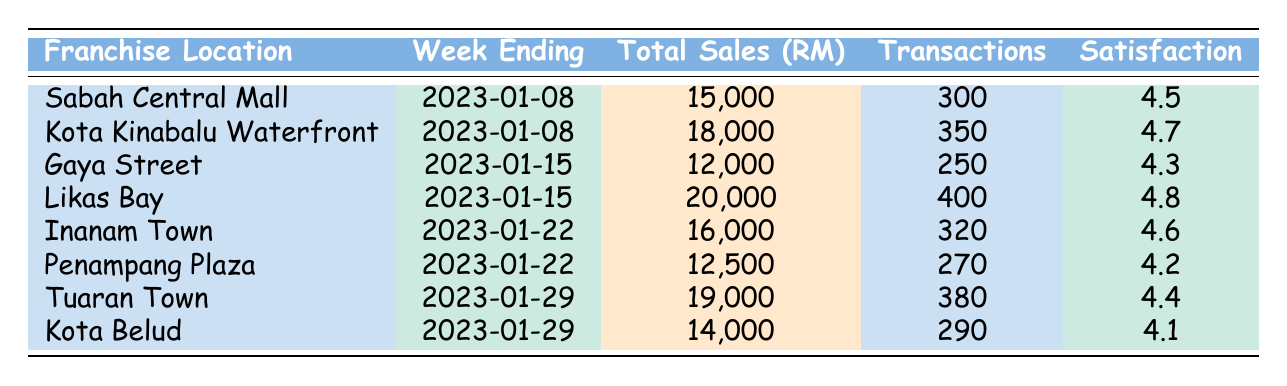What was the highest total sales recorded in a week and where was it? From the table, we look at the Total Sales column. The highest value is 20,000, located at Likas Bay for the week ending on 2023-01-15.
Answer: 20,000 at Likas Bay Which franchise location had the lowest customer satisfaction rating? We need to compare the Customer Satisfaction Rating of each location. The lowest rating in the table is 4.1 for Kota Belud.
Answer: Kota Belud What is the average total sales for the franchises over the recorded weeks? We sum the total sales: 15000 + 18000 + 12000 + 20000 + 16000 + 12500 + 19000 + 14000 = 1,15000. There are 8 locations, so the average is 115000 / 8 = 14375.
Answer: 14375 Did Inanam Town have more transactions than Gaya Street in their respective weeks? Checking the Number of Transactions for Inanam Town (320) and Gaya Street (250), we find that Inanam Town had more transactions.
Answer: Yes What is the difference in total sales between Likas Bay and Kota Belud? We subtract Kota Belud's total sales (14,000) from Likas Bay's (20,000): 20000 - 14000 = 6000.
Answer: 6000 Which week had the highest average transaction value? We compare the Average Transaction Value of each location. The highest value is 51.43 at Kota Kinabalu Waterfront for the week ending on 2023-01-08.
Answer: 51.43 at Kota Kinabalu Waterfront Did any franchise locations record total sales below 15,000? We need to check each total sales figure. Yes, Gaya Street (12,000) and Penampang Plaza (12,500) are below 15,000.
Answer: Yes Which franchise location had the highest number of transactions in a week? Looking through the Number of Transactions, Likas Bay with 400 transactions has the highest figure recorded in the table.
Answer: Likas Bay with 400 transactions 